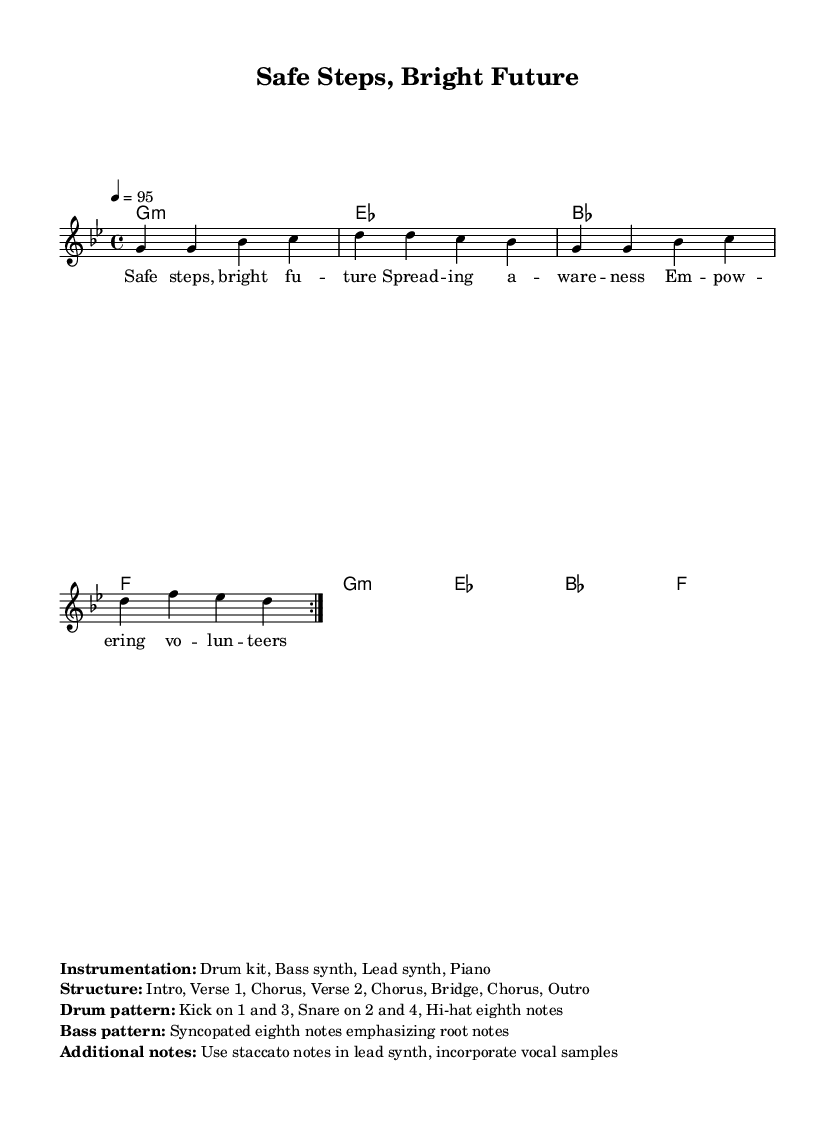What is the key signature of this music? The key signature is G minor, which is indicated by two flats: Bb and Eb.
Answer: G minor What is the time signature of this music? The time signature is 4/4, meaning there are four beats in each measure, and the quarter note gets one beat.
Answer: 4/4 What is the tempo indicated for this piece? The tempo marking is 95, indicating that the quarter note should be played at 95 beats per minute.
Answer: 95 How many times is the main melody repeated? The main melody is repeated 2 times, as indicated by the \repeat volta 2 directive before the melody notations.
Answer: 2 times What is the instrumental arrangement mentioned in the markup? The instrumentation includes a Drum kit, Bass synth, Lead synth, and Piano, as detailed in the markup section.
Answer: Drum kit, Bass synth, Lead synth, Piano What is the structure of this hip-hop anthem? The structure consists of Intro, Verse 1, Chorus, Verse 2, Chorus, Bridge, Chorus, and Outro, which provides a clear organization of the song.
Answer: Intro, Verse 1, Chorus, Verse 2, Chorus, Bridge, Chorus, Outro What type of bass pattern is used in this hip-hop piece? The bass pattern is syncopated eighth notes emphasizing root notes, which is characteristic of hip-hop music for creating groove and rhythm.
Answer: Syncopated eighth notes 